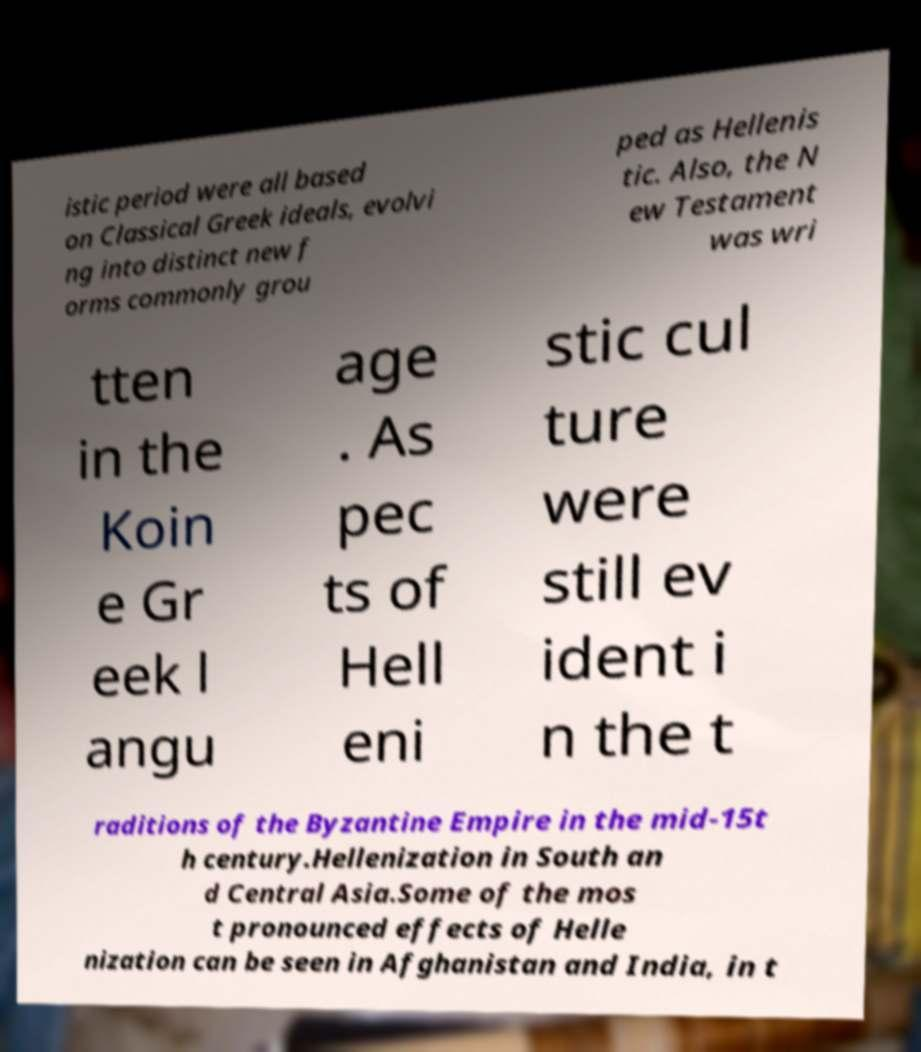Could you assist in decoding the text presented in this image and type it out clearly? istic period were all based on Classical Greek ideals, evolvi ng into distinct new f orms commonly grou ped as Hellenis tic. Also, the N ew Testament was wri tten in the Koin e Gr eek l angu age . As pec ts of Hell eni stic cul ture were still ev ident i n the t raditions of the Byzantine Empire in the mid-15t h century.Hellenization in South an d Central Asia.Some of the mos t pronounced effects of Helle nization can be seen in Afghanistan and India, in t 